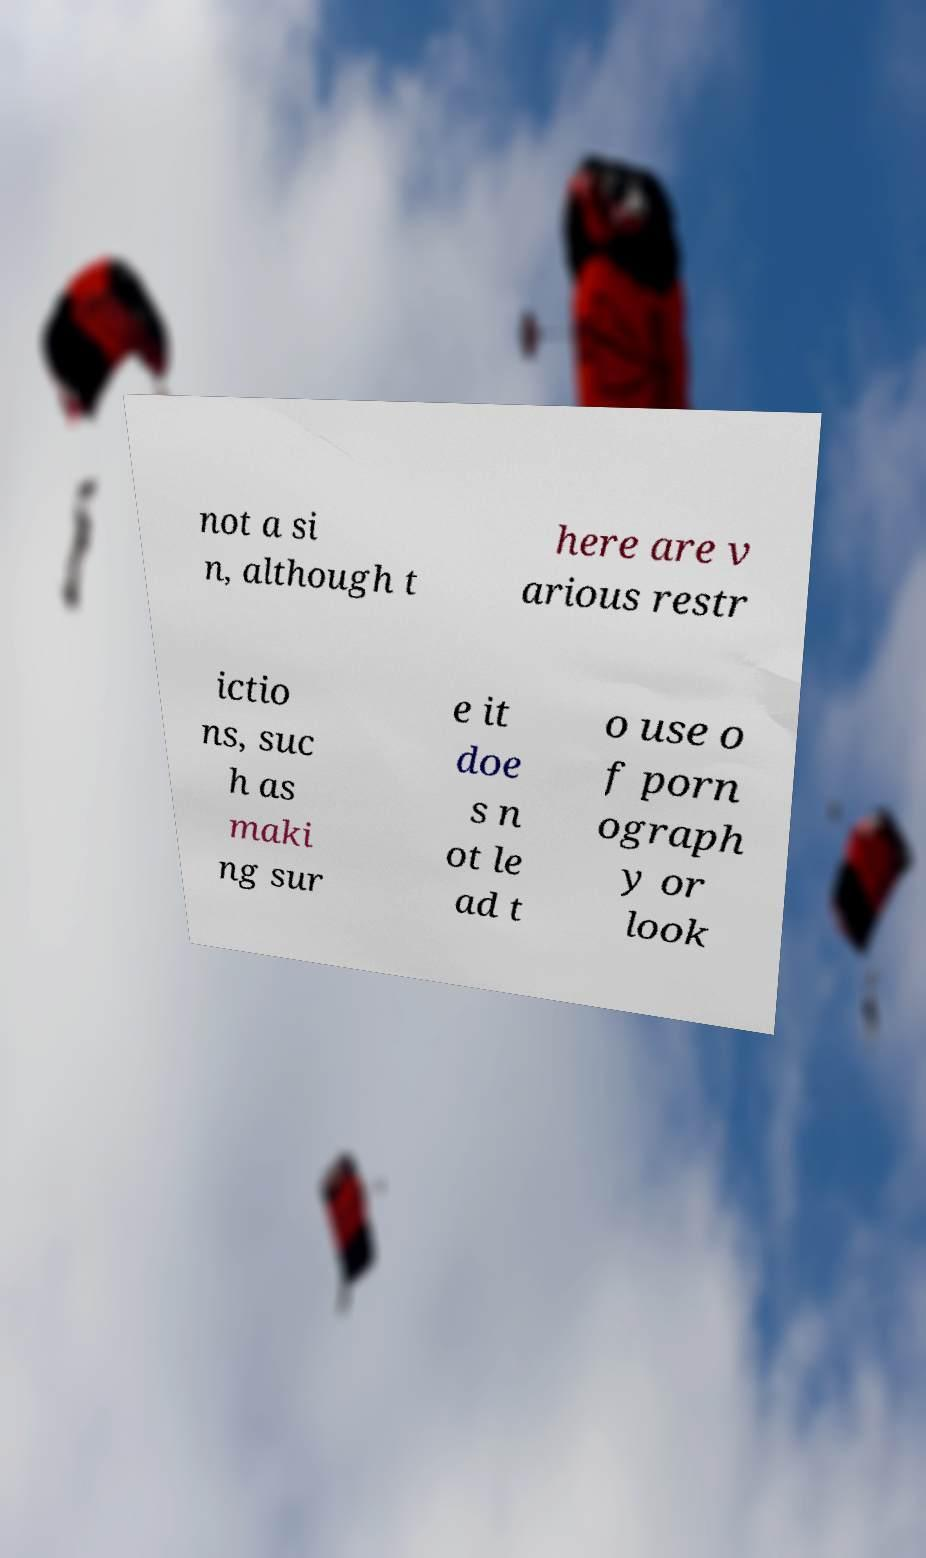Can you read and provide the text displayed in the image?This photo seems to have some interesting text. Can you extract and type it out for me? not a si n, although t here are v arious restr ictio ns, suc h as maki ng sur e it doe s n ot le ad t o use o f porn ograph y or look 